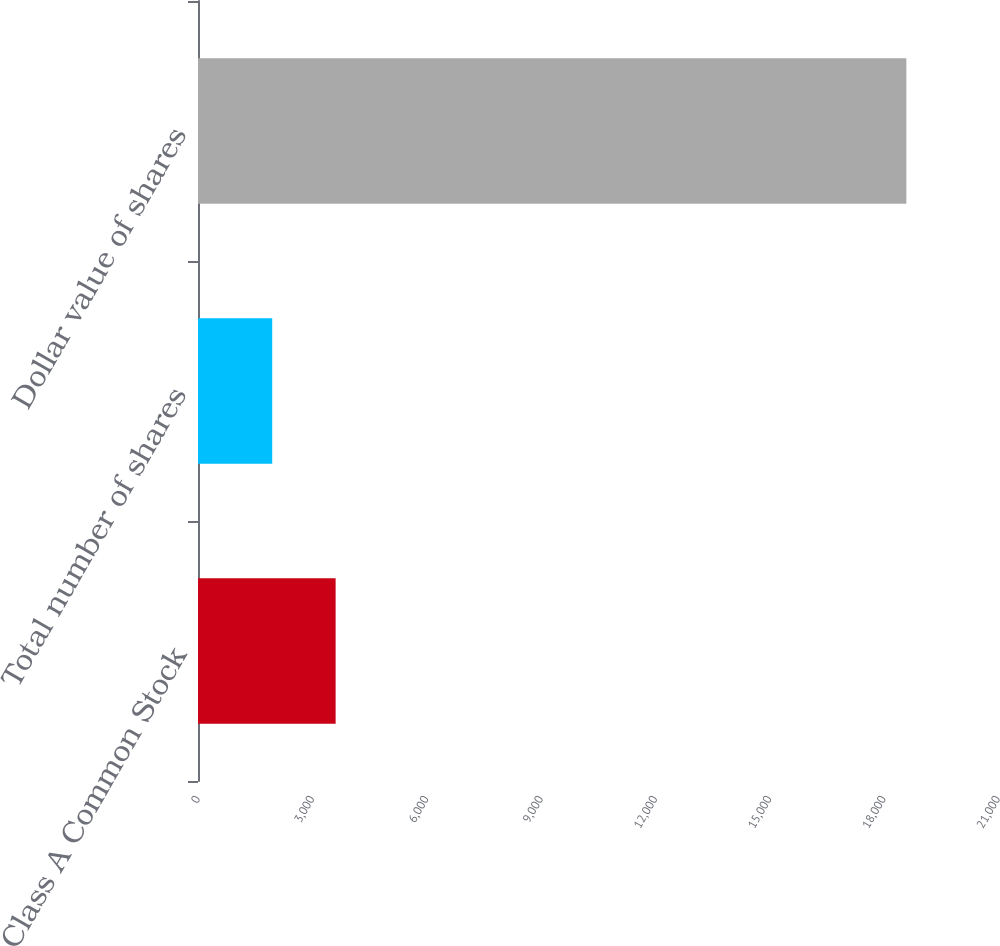<chart> <loc_0><loc_0><loc_500><loc_500><bar_chart><fcel>Class A Common Stock<fcel>Total number of shares<fcel>Dollar value of shares<nl><fcel>3612.6<fcel>1948<fcel>18594<nl></chart> 